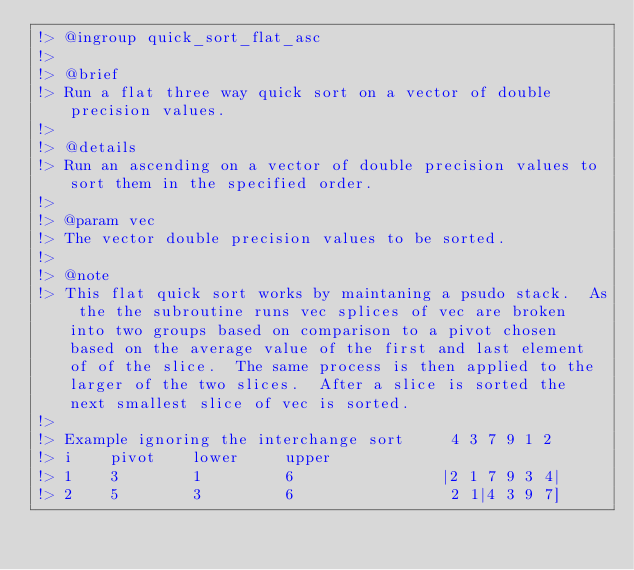Convert code to text. <code><loc_0><loc_0><loc_500><loc_500><_FORTRAN_>!> @ingroup quick_sort_flat_asc
!> 
!> @brief 
!> Run a flat three way quick sort on a vector of double precision values. 
!>
!> @details 
!> Run an ascending on a vector of double precision values to sort them in the specified order.
!>
!> @param vec
!> The vector double precision values to be sorted.
!>
!> @note
!> This flat quick sort works by maintaning a psudo stack.  As the the subroutine runs vec splices of vec are broken into two groups based on comparison to a pivot chosen based on the average value of the first and last element of of the slice.  The same process is then applied to the larger of the two slices.  After a slice is sorted the next smallest slice of vec is sorted.  
!> 
!> Example ignoring the interchange sort     4 3 7 9 1 2
!> i    pivot    lower     upper   
!> 1    3        1         6                |2 1 7 9 3 4|
!> 2    5        3         6                 2 1|4 3 9 7]</code> 